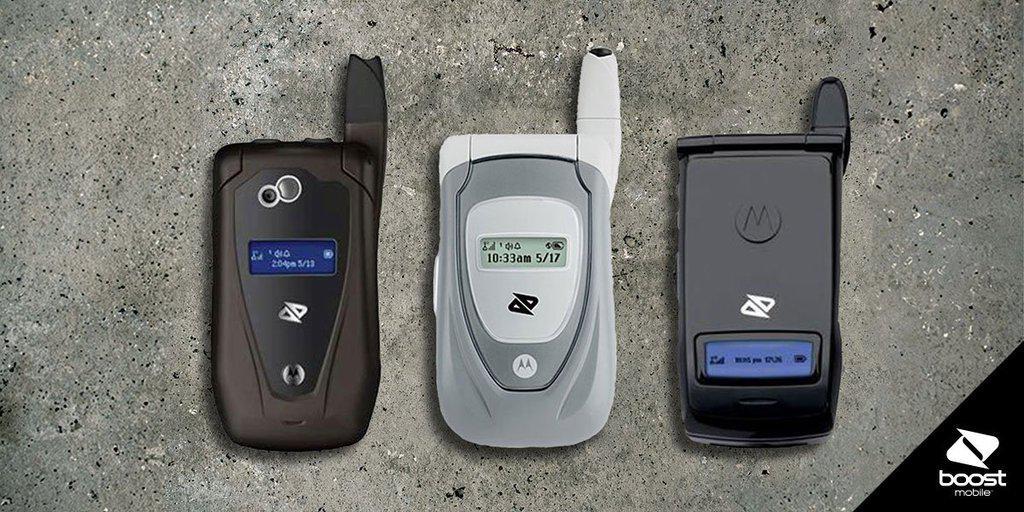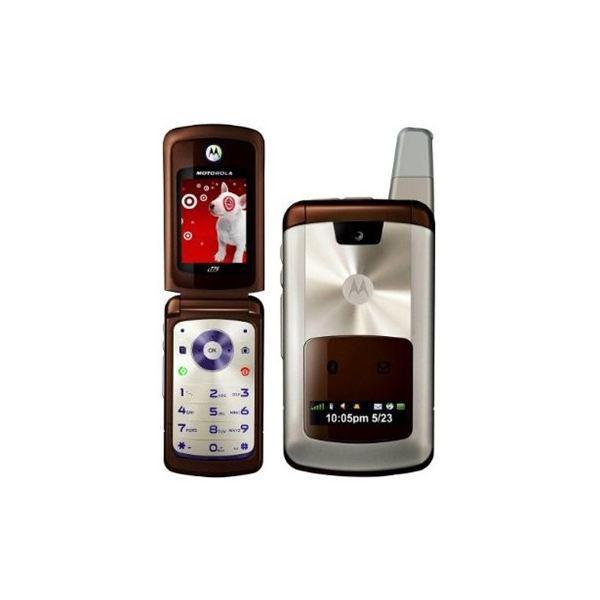The first image is the image on the left, the second image is the image on the right. Assess this claim about the two images: "Every phone is a flip phone.". Correct or not? Answer yes or no. Yes. The first image is the image on the left, the second image is the image on the right. Analyze the images presented: Is the assertion "All of the phones are flip-phones; they can be physically unfolded to open them." valid? Answer yes or no. Yes. 